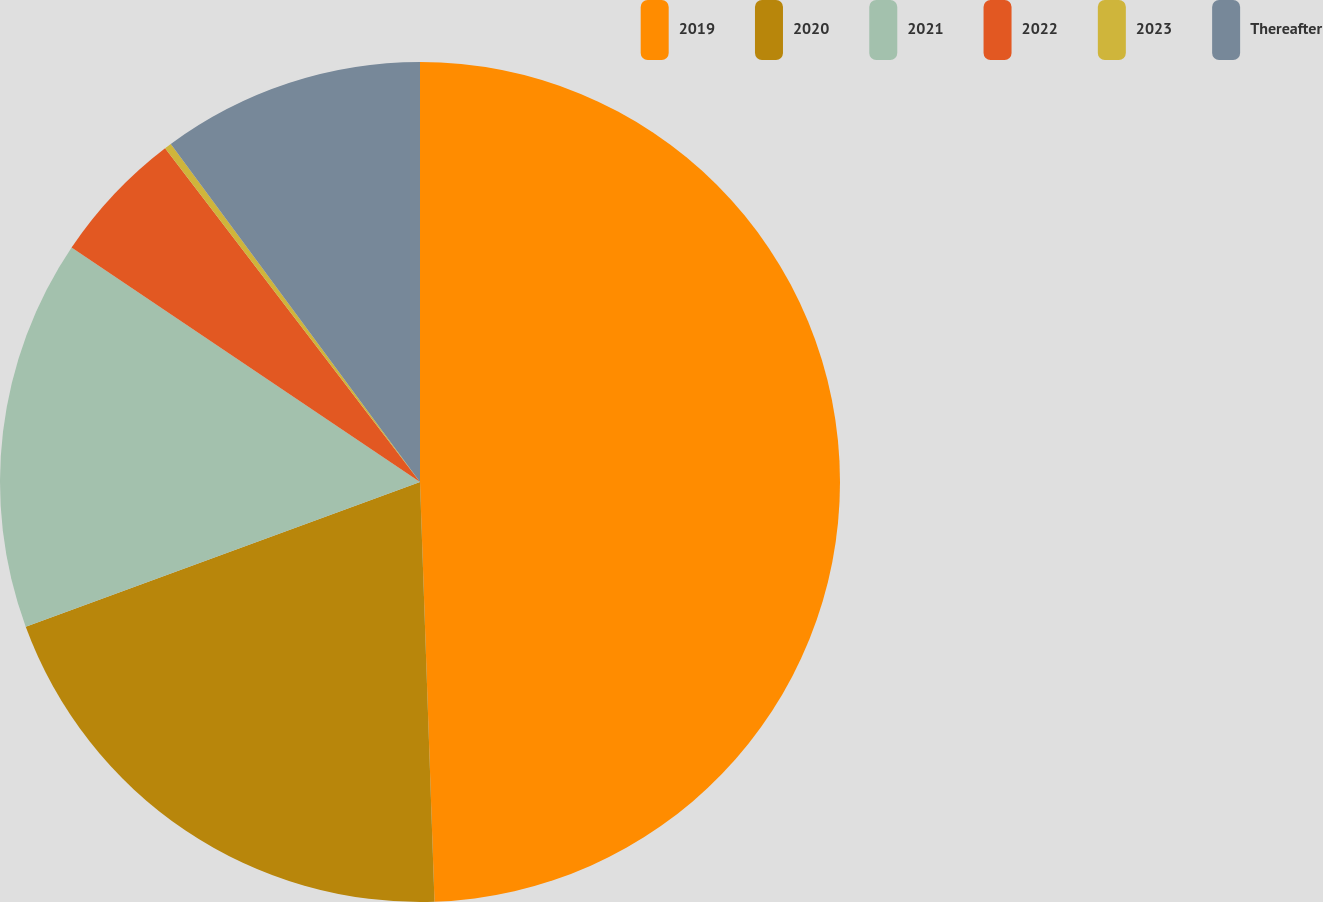<chart> <loc_0><loc_0><loc_500><loc_500><pie_chart><fcel>2019<fcel>2020<fcel>2021<fcel>2022<fcel>2023<fcel>Thereafter<nl><fcel>49.45%<fcel>19.95%<fcel>15.03%<fcel>5.19%<fcel>0.27%<fcel>10.11%<nl></chart> 